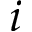Convert formula to latex. <formula><loc_0><loc_0><loc_500><loc_500>i</formula> 